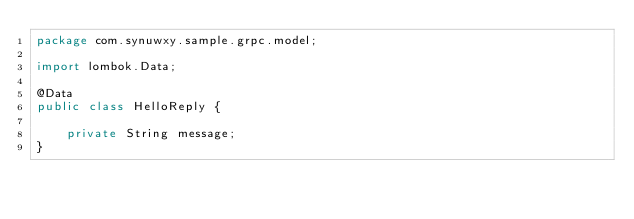Convert code to text. <code><loc_0><loc_0><loc_500><loc_500><_Java_>package com.synuwxy.sample.grpc.model;

import lombok.Data;

@Data
public class HelloReply {

    private String message;
}
</code> 